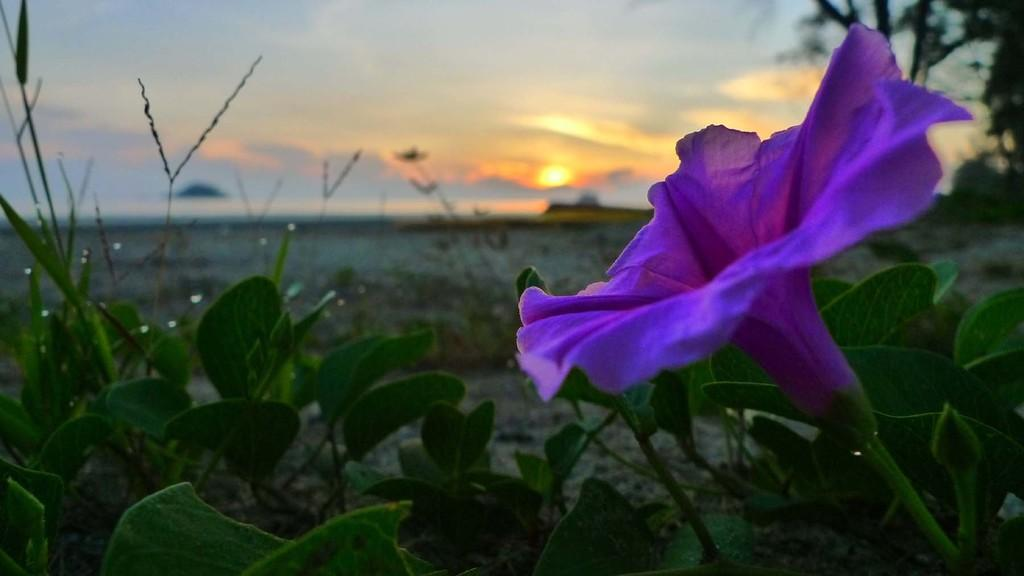What type of plant can be seen in the image? There is a flower in the image. Are there any other plants visible besides the flower? Yes, there are plants in the image. What can be seen beneath the plants and flower? The ground is visible in the image. What is visible above the plants and flower? The sky is visible in the image, with clouds and the sun present. What type of religion is being practiced in the image? There is no indication of any religious practice in the image; it features a flower, plants, ground, and sky. How many frogs can be seen in the image? There are no frogs present in the image. 